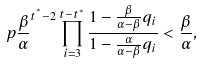Convert formula to latex. <formula><loc_0><loc_0><loc_500><loc_500>\ p { \frac { \beta } { \alpha } } ^ { t ^ { ^ { * } } - 2 } \prod _ { i = 3 } ^ { t - t ^ { * } } \frac { 1 - \frac { \beta } { \alpha - \beta } q _ { i } } { 1 - \frac { \alpha } { \alpha - \beta } q _ { i } } < \frac { \beta } { \alpha } ,</formula> 